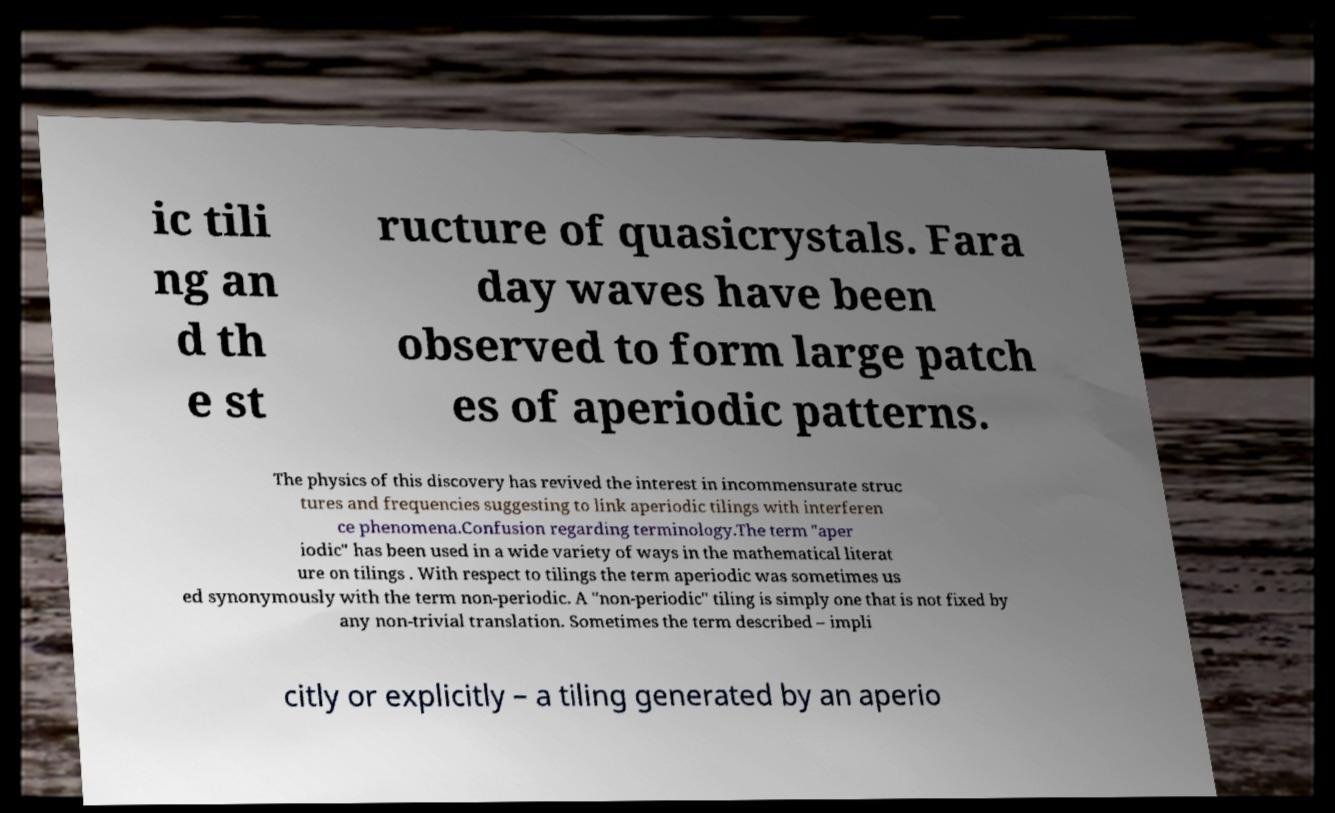Could you assist in decoding the text presented in this image and type it out clearly? ic tili ng an d th e st ructure of quasicrystals. Fara day waves have been observed to form large patch es of aperiodic patterns. The physics of this discovery has revived the interest in incommensurate struc tures and frequencies suggesting to link aperiodic tilings with interferen ce phenomena.Confusion regarding terminology.The term "aper iodic" has been used in a wide variety of ways in the mathematical literat ure on tilings . With respect to tilings the term aperiodic was sometimes us ed synonymously with the term non-periodic. A "non-periodic" tiling is simply one that is not fixed by any non-trivial translation. Sometimes the term described – impli citly or explicitly – a tiling generated by an aperio 